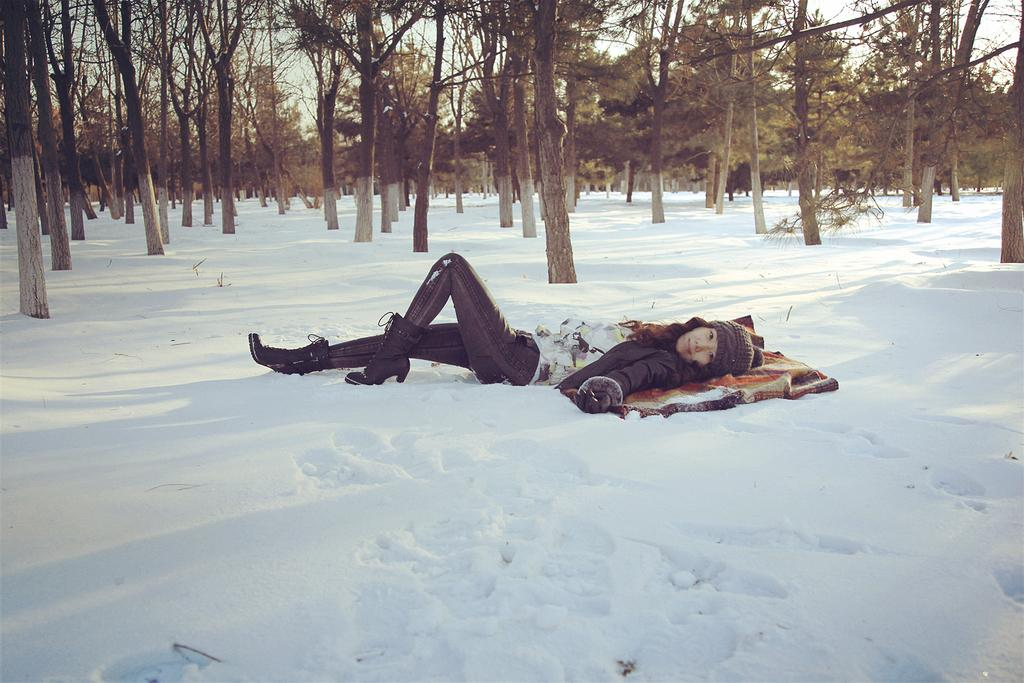Who is present in the image? There is a woman in the image. What is the woman doing in the image? The woman is laying on the snow. What can be seen in the background of the image? There are trees in the background of the image. What type of fish can be seen swimming in the snow in the image? There are no fish present in the image, and fish cannot swim in snow. 